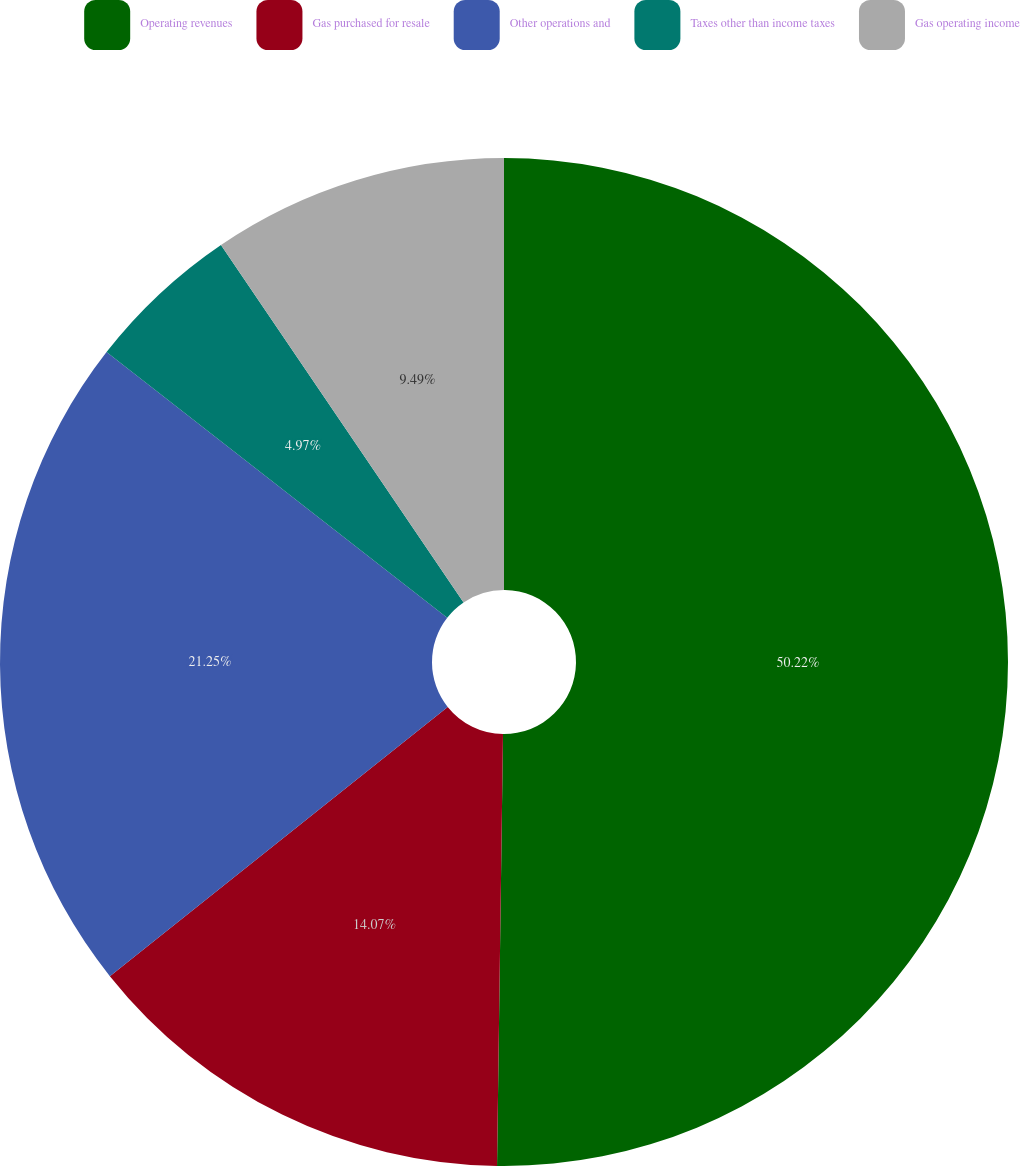<chart> <loc_0><loc_0><loc_500><loc_500><pie_chart><fcel>Operating revenues<fcel>Gas purchased for resale<fcel>Other operations and<fcel>Taxes other than income taxes<fcel>Gas operating income<nl><fcel>50.22%<fcel>14.07%<fcel>21.25%<fcel>4.97%<fcel>9.49%<nl></chart> 